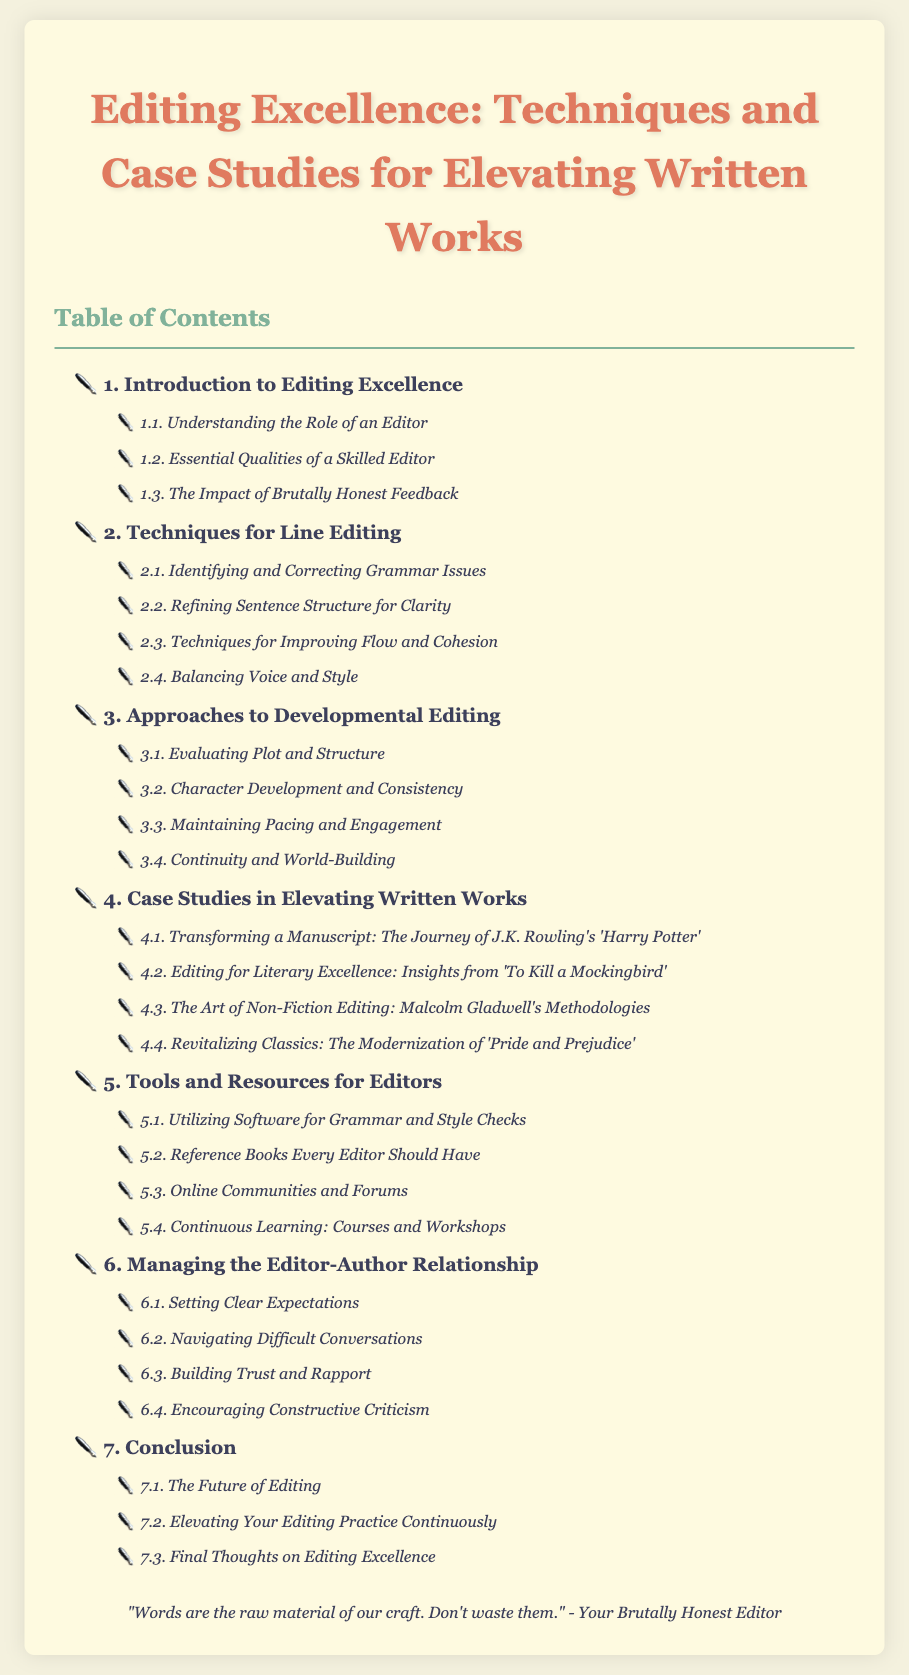What is the title of the document? The title is clearly stated at the top of the document and is "Editing Excellence: Techniques and Case Studies for Elevating Written Works."
Answer: Editing Excellence: Techniques and Case Studies for Elevating Written Works How many chapters are listed in the Table of Contents? The chapters are numbered, and there are a total of seven chapters in the Table of Contents.
Answer: 7 What section focuses on character development? The section titled "3.2. Character Development and Consistency" specifically addresses character development within the context of editing.
Answer: 3.2. Character Development and Consistency Which literary work is connected to the chapter on case studies? The case studies chapter includes various examples, notably "To Kill a Mockingbird," which is referenced under case studies in editing for literary excellence.
Answer: To Kill a Mockingbird What is one of the essential qualities of a skilled editor? The document mentions several qualities but specifically highlights "Essential Qualities of a Skilled Editor" as a section within the introduction to editing excellence.
Answer: Essential Qualities of a Skilled Editor What is the focus of section 5.1? Section 5.1 is dedicated to software utilization specifically for grammar and style checks, making it clear what resources editors can utilize.
Answer: Utilizing Software for Grammar and Style Checks What does chapter six address? Chapter six is focused on the dynamics of the editor-author relationship, indicating the importance of this aspect in editing practices.
Answer: Managing the Editor-Author Relationship 